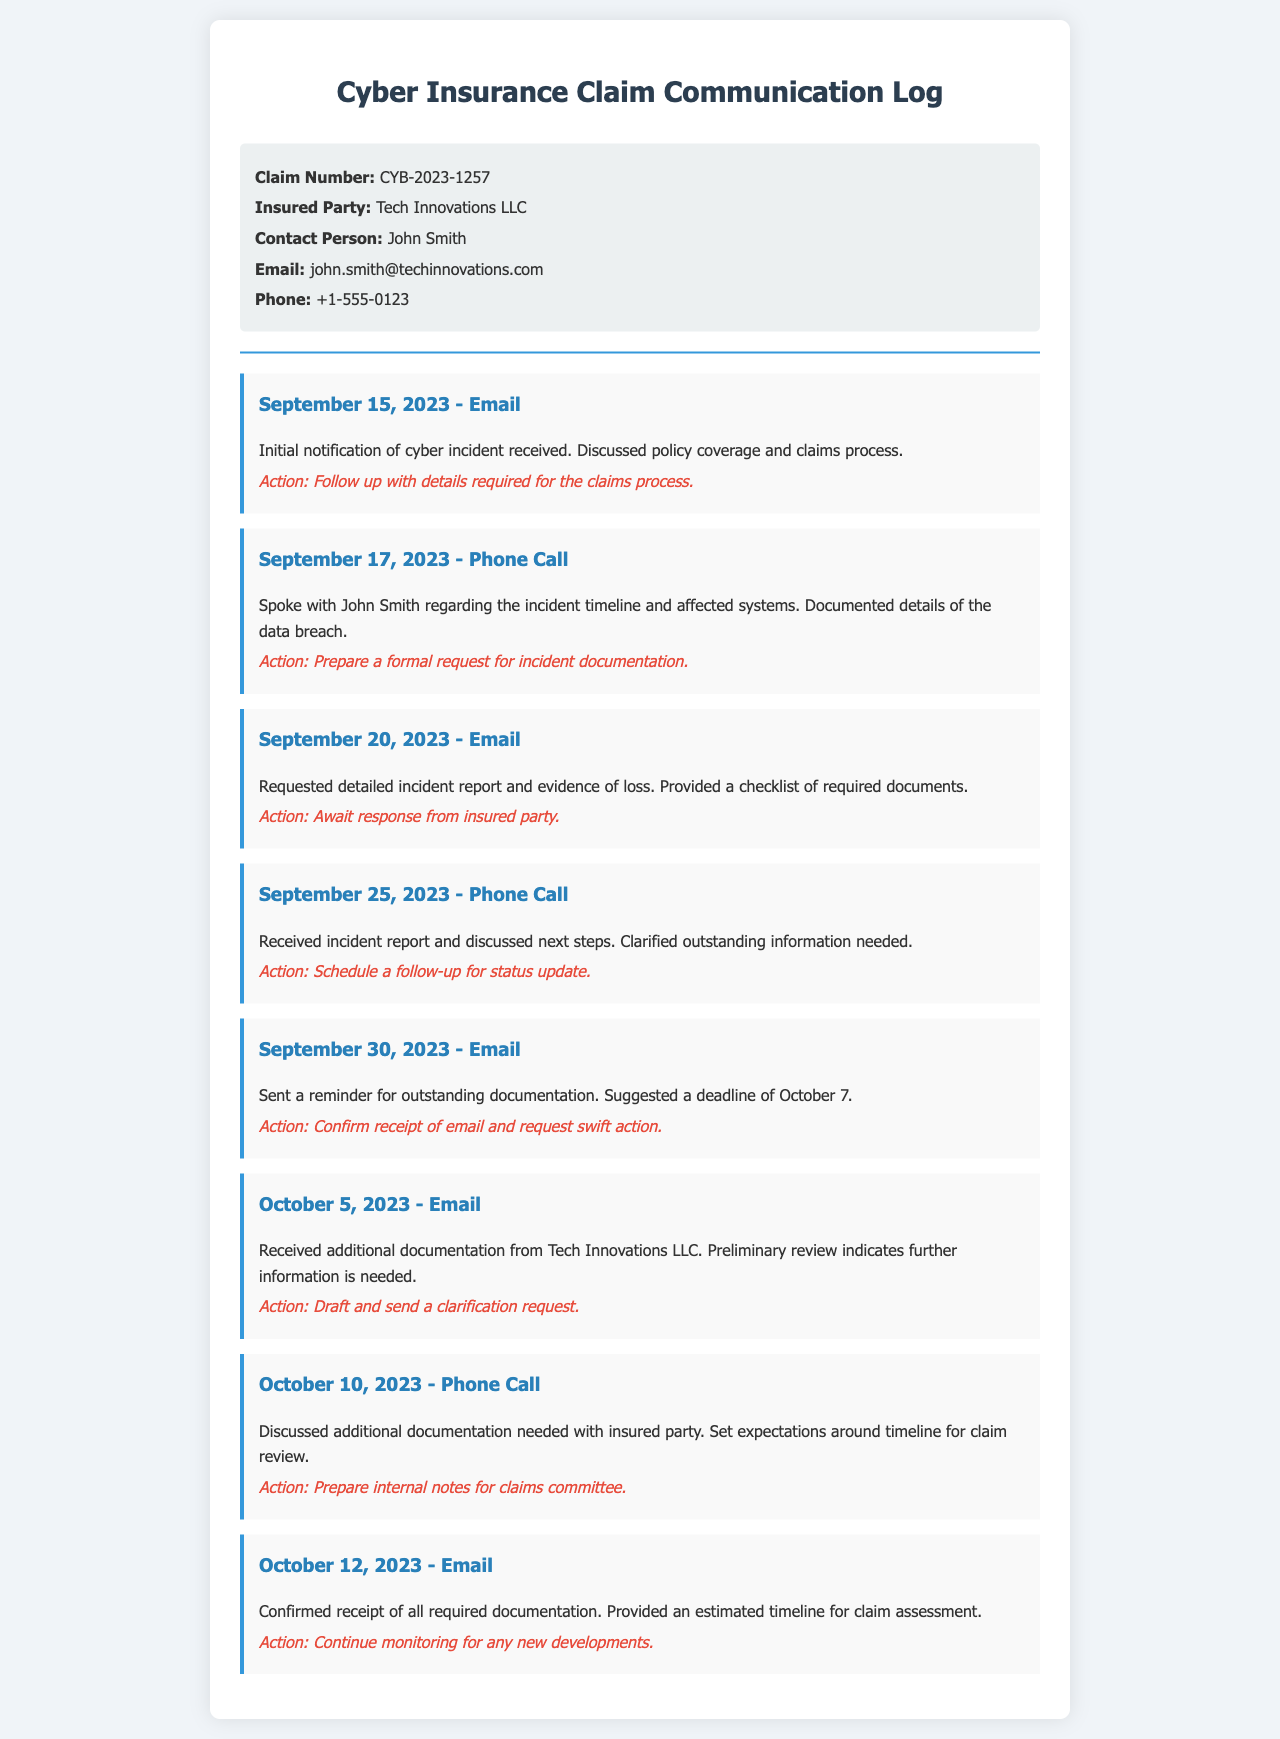What is the claim number? The claim number is listed in the document under the claim information section.
Answer: CYB-2023-1257 Who is the contact person for the insured party? The contact person is mentioned in the claim info section of the document.
Answer: John Smith What date was the initial notification of the cyber incident received? The date of the initial notification is provided in the communication log.
Answer: September 15, 2023 What was requested in the email sent on September 20, 2023? The email details are specified in the log with the type of request indicated.
Answer: Incident report and evidence of loss What action was taken after the phone call on October 10, 2023? The communication entry outlines the follow-up action discussed in that phone call.
Answer: Prepare internal notes for claims committee How many times did the insured party receive an email as part of the communication? This can be determined by counting the entries in the communication log specifically categorized as emails.
Answer: Four What was the suggested deadline for outstanding documentation? The deadline is stated explicitly in the email mentioned in the communication log.
Answer: October 7 What does the preliminary review of documentation received on October 5 indicate? The review results are mentioned in the relevant entry of the communication log.
Answer: Further information is needed What is the purpose of the confirmed receipt email sent on October 12, 2023? The purpose is stated clearly in the communication entry; it relates to the documentation and timeline.
Answer: Estimate timeline for claim assessment 